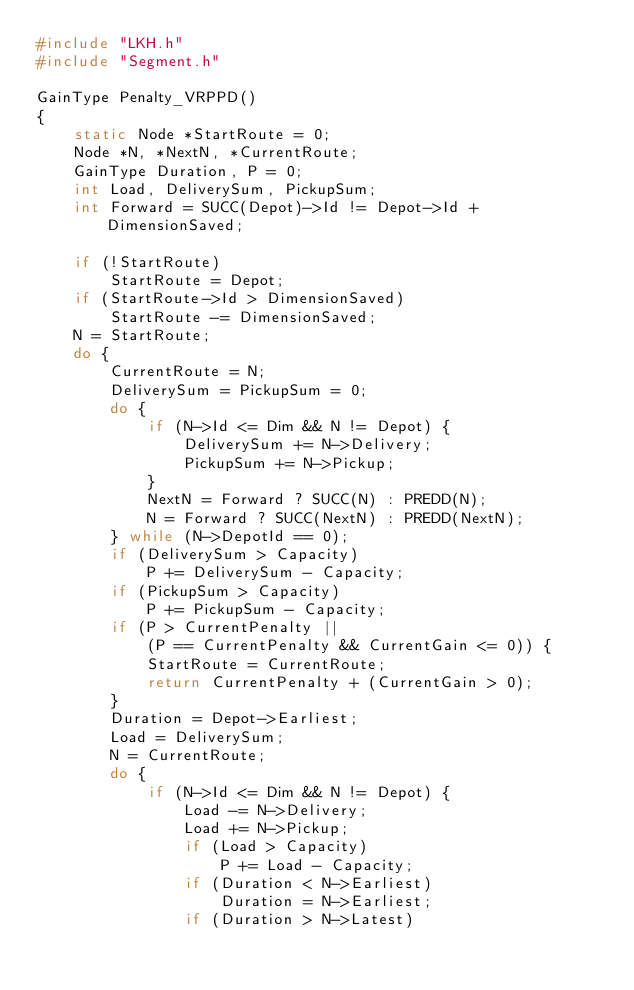<code> <loc_0><loc_0><loc_500><loc_500><_C_>#include "LKH.h"
#include "Segment.h"

GainType Penalty_VRPPD()
{
    static Node *StartRoute = 0;
    Node *N, *NextN, *CurrentRoute;
    GainType Duration, P = 0;
    int Load, DeliverySum, PickupSum;
    int Forward = SUCC(Depot)->Id != Depot->Id + DimensionSaved;

    if (!StartRoute)
        StartRoute = Depot;
    if (StartRoute->Id > DimensionSaved)
        StartRoute -= DimensionSaved;
    N = StartRoute;
    do {
        CurrentRoute = N;
        DeliverySum = PickupSum = 0;
        do {
            if (N->Id <= Dim && N != Depot) {
                DeliverySum += N->Delivery;
                PickupSum += N->Pickup;
            }
            NextN = Forward ? SUCC(N) : PREDD(N);
            N = Forward ? SUCC(NextN) : PREDD(NextN);
        } while (N->DepotId == 0);
        if (DeliverySum > Capacity)
            P += DeliverySum - Capacity;
        if (PickupSum > Capacity)
            P += PickupSum - Capacity;
        if (P > CurrentPenalty ||
            (P == CurrentPenalty && CurrentGain <= 0)) {
            StartRoute = CurrentRoute;
            return CurrentPenalty + (CurrentGain > 0);
        }
        Duration = Depot->Earliest;
        Load = DeliverySum;
        N = CurrentRoute;
        do {
            if (N->Id <= Dim && N != Depot) {
                Load -= N->Delivery;
                Load += N->Pickup;
                if (Load > Capacity)
                    P += Load - Capacity;
                if (Duration < N->Earliest)
                    Duration = N->Earliest;
                if (Duration > N->Latest)</code> 